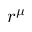<formula> <loc_0><loc_0><loc_500><loc_500>r ^ { \mu }</formula> 